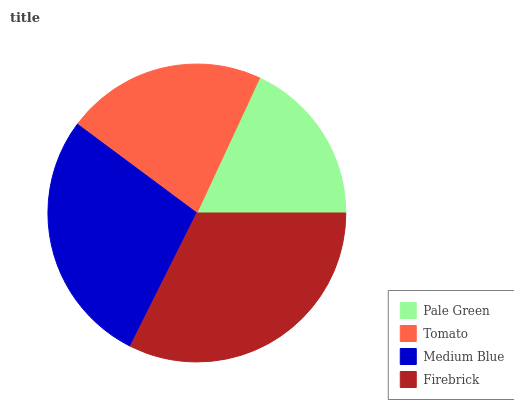Is Pale Green the minimum?
Answer yes or no. Yes. Is Firebrick the maximum?
Answer yes or no. Yes. Is Tomato the minimum?
Answer yes or no. No. Is Tomato the maximum?
Answer yes or no. No. Is Tomato greater than Pale Green?
Answer yes or no. Yes. Is Pale Green less than Tomato?
Answer yes or no. Yes. Is Pale Green greater than Tomato?
Answer yes or no. No. Is Tomato less than Pale Green?
Answer yes or no. No. Is Medium Blue the high median?
Answer yes or no. Yes. Is Tomato the low median?
Answer yes or no. Yes. Is Tomato the high median?
Answer yes or no. No. Is Firebrick the low median?
Answer yes or no. No. 